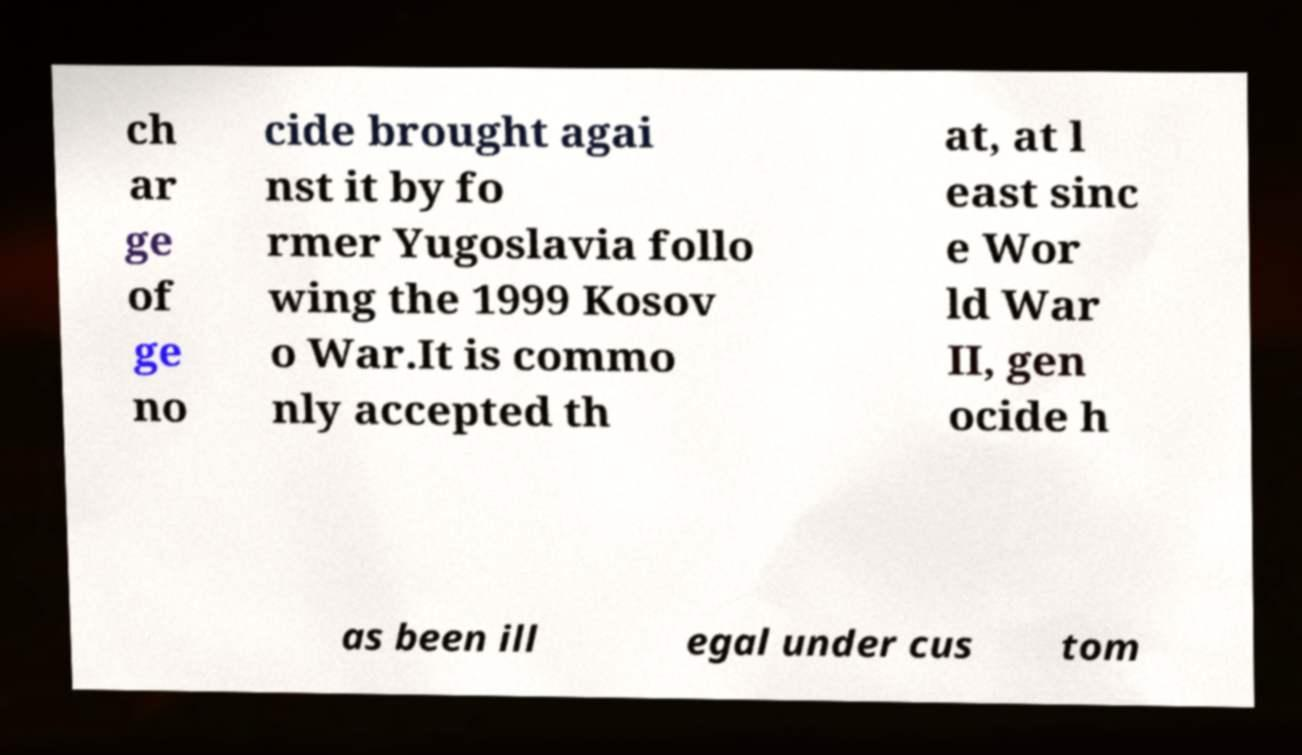Could you extract and type out the text from this image? ch ar ge of ge no cide brought agai nst it by fo rmer Yugoslavia follo wing the 1999 Kosov o War.It is commo nly accepted th at, at l east sinc e Wor ld War II, gen ocide h as been ill egal under cus tom 